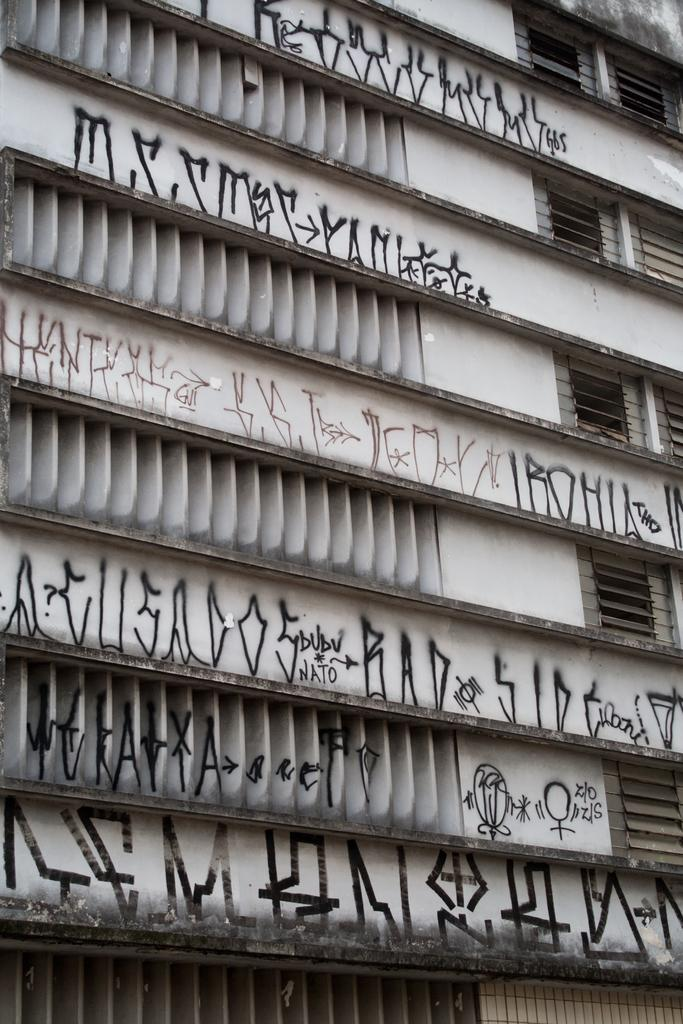What is the main subject of the image? The main subject of the image is a building. Can you describe the building in the image? The building has windows and text on it. How many pears are hanging from the plants in the image? There are no pears or plants present in the image; it features a building with windows and text. What type of exchange is taking place in the image? There is no exchange depicted in the image; it only shows a building with windows and text. 